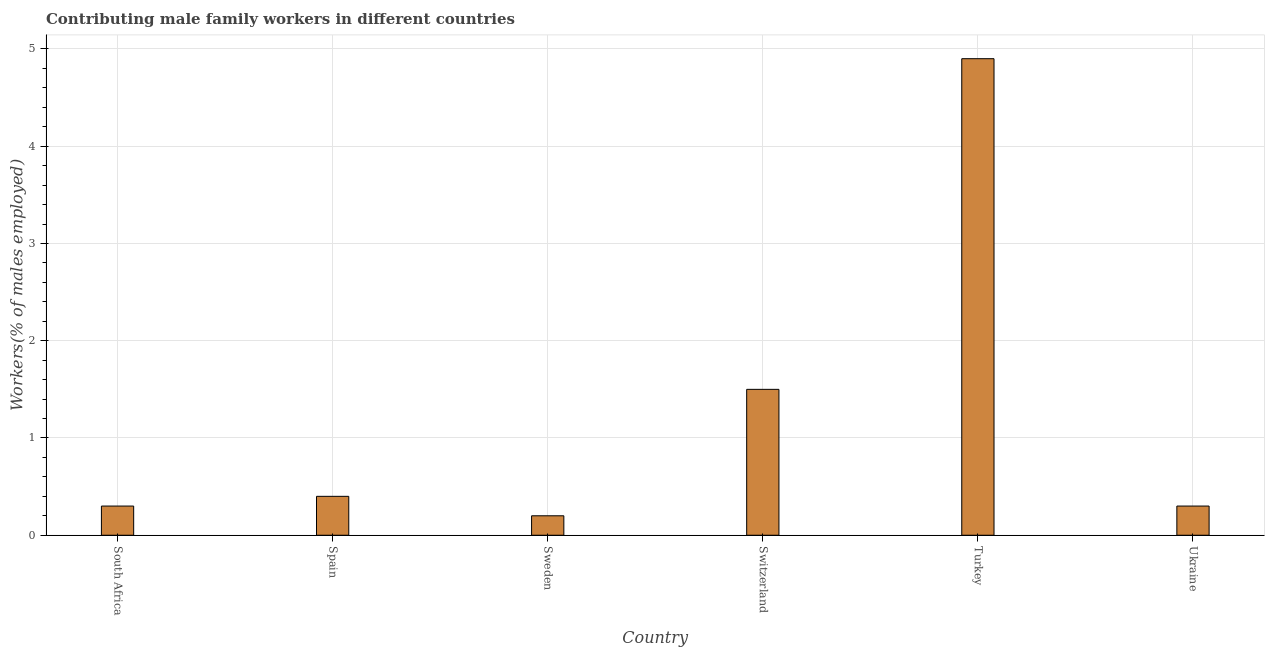What is the title of the graph?
Your response must be concise. Contributing male family workers in different countries. What is the label or title of the X-axis?
Provide a short and direct response. Country. What is the label or title of the Y-axis?
Offer a very short reply. Workers(% of males employed). Across all countries, what is the maximum contributing male family workers?
Ensure brevity in your answer.  4.9. Across all countries, what is the minimum contributing male family workers?
Your response must be concise. 0.2. What is the sum of the contributing male family workers?
Offer a terse response. 7.6. What is the difference between the contributing male family workers in Switzerland and Turkey?
Provide a succinct answer. -3.4. What is the average contributing male family workers per country?
Ensure brevity in your answer.  1.27. What is the median contributing male family workers?
Offer a very short reply. 0.35. What is the ratio of the contributing male family workers in South Africa to that in Sweden?
Your answer should be very brief. 1.5. Is the contributing male family workers in Turkey less than that in Ukraine?
Your response must be concise. No. Is the difference between the contributing male family workers in Sweden and Turkey greater than the difference between any two countries?
Make the answer very short. Yes. How many bars are there?
Ensure brevity in your answer.  6. Are all the bars in the graph horizontal?
Provide a short and direct response. No. What is the difference between two consecutive major ticks on the Y-axis?
Provide a short and direct response. 1. Are the values on the major ticks of Y-axis written in scientific E-notation?
Your response must be concise. No. What is the Workers(% of males employed) of South Africa?
Make the answer very short. 0.3. What is the Workers(% of males employed) of Spain?
Offer a very short reply. 0.4. What is the Workers(% of males employed) of Sweden?
Offer a very short reply. 0.2. What is the Workers(% of males employed) of Turkey?
Keep it short and to the point. 4.9. What is the Workers(% of males employed) of Ukraine?
Your answer should be compact. 0.3. What is the difference between the Workers(% of males employed) in South Africa and Sweden?
Provide a short and direct response. 0.1. What is the difference between the Workers(% of males employed) in Spain and Ukraine?
Give a very brief answer. 0.1. What is the difference between the Workers(% of males employed) in Sweden and Switzerland?
Give a very brief answer. -1.3. What is the difference between the Workers(% of males employed) in Sweden and Turkey?
Make the answer very short. -4.7. What is the difference between the Workers(% of males employed) in Sweden and Ukraine?
Make the answer very short. -0.1. What is the difference between the Workers(% of males employed) in Switzerland and Ukraine?
Your response must be concise. 1.2. What is the ratio of the Workers(% of males employed) in South Africa to that in Sweden?
Your answer should be compact. 1.5. What is the ratio of the Workers(% of males employed) in South Africa to that in Switzerland?
Keep it short and to the point. 0.2. What is the ratio of the Workers(% of males employed) in South Africa to that in Turkey?
Provide a short and direct response. 0.06. What is the ratio of the Workers(% of males employed) in Spain to that in Sweden?
Offer a terse response. 2. What is the ratio of the Workers(% of males employed) in Spain to that in Switzerland?
Provide a succinct answer. 0.27. What is the ratio of the Workers(% of males employed) in Spain to that in Turkey?
Ensure brevity in your answer.  0.08. What is the ratio of the Workers(% of males employed) in Spain to that in Ukraine?
Give a very brief answer. 1.33. What is the ratio of the Workers(% of males employed) in Sweden to that in Switzerland?
Your answer should be very brief. 0.13. What is the ratio of the Workers(% of males employed) in Sweden to that in Turkey?
Keep it short and to the point. 0.04. What is the ratio of the Workers(% of males employed) in Sweden to that in Ukraine?
Provide a succinct answer. 0.67. What is the ratio of the Workers(% of males employed) in Switzerland to that in Turkey?
Keep it short and to the point. 0.31. What is the ratio of the Workers(% of males employed) in Switzerland to that in Ukraine?
Keep it short and to the point. 5. What is the ratio of the Workers(% of males employed) in Turkey to that in Ukraine?
Provide a succinct answer. 16.33. 